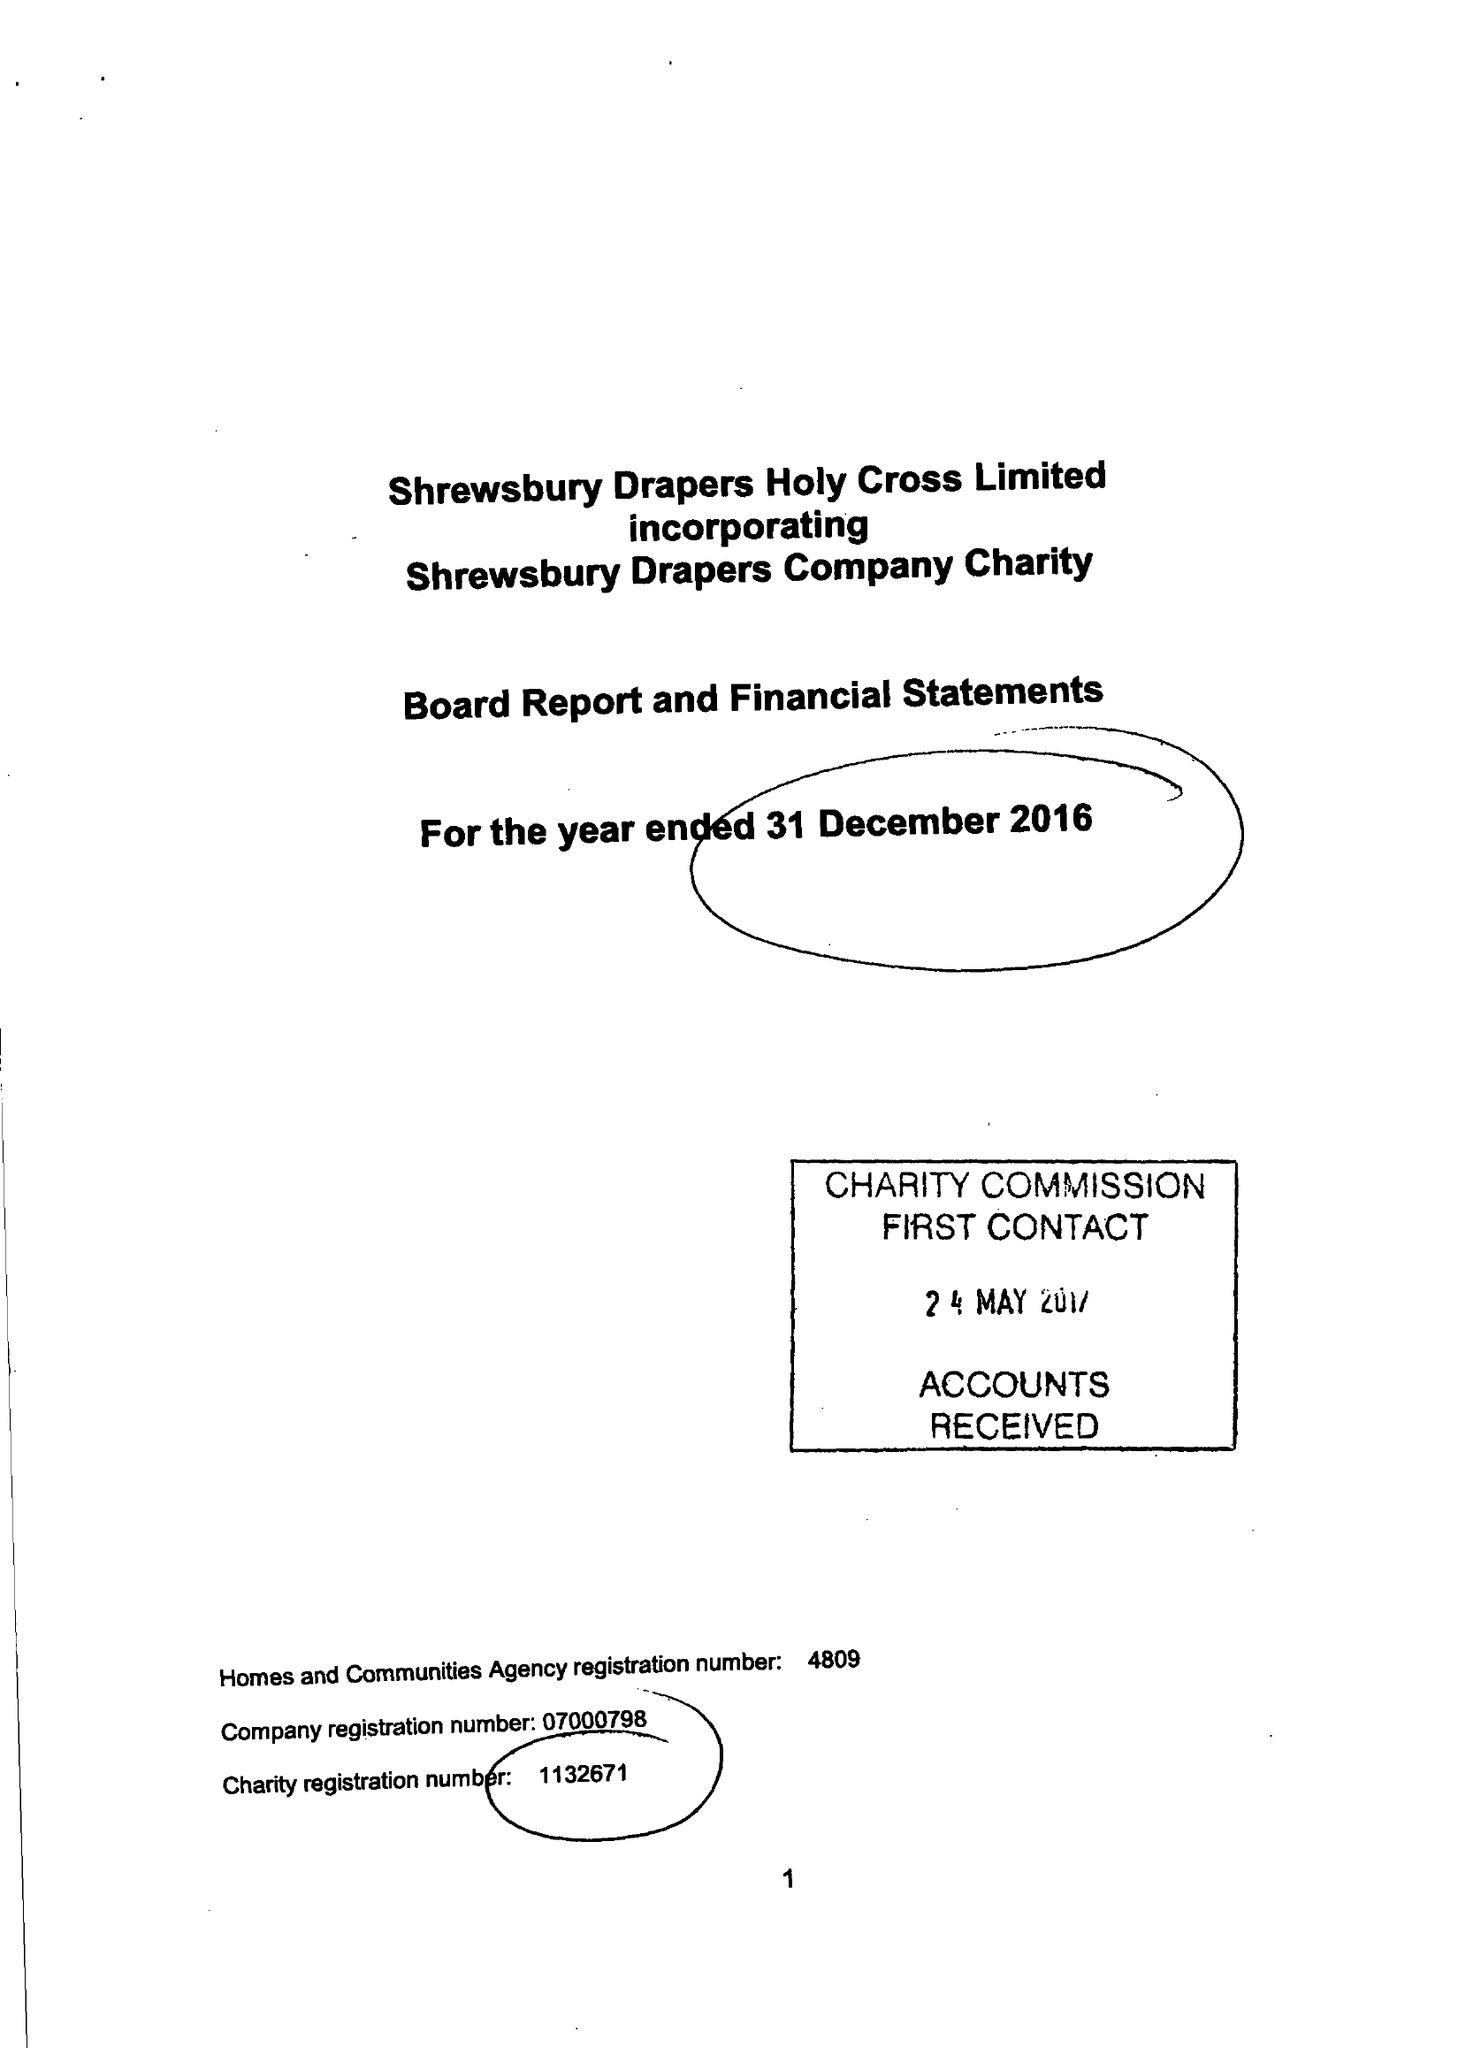What is the value for the spending_annually_in_british_pounds?
Answer the question using a single word or phrase. 89705.00 